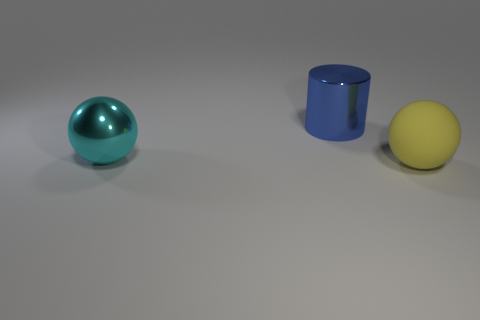There is a large yellow rubber thing; is its shape the same as the large metal thing on the left side of the cylinder?
Offer a very short reply. Yes. There is a large cyan object that is made of the same material as the big cylinder; what is its shape?
Offer a very short reply. Sphere. Are there more large blue cylinders that are behind the cyan thing than large blue cylinders that are behind the blue object?
Make the answer very short. Yes. What number of things are blue metallic cylinders or blue matte balls?
Give a very brief answer. 1. How many other things are the same color as the metal cylinder?
Offer a terse response. 0. There is a blue shiny thing that is the same size as the cyan ball; what shape is it?
Give a very brief answer. Cylinder. What color is the ball that is on the left side of the large rubber thing?
Your answer should be compact. Cyan. How many things are either large spheres that are to the left of the large yellow matte object or objects in front of the metal cylinder?
Give a very brief answer. 2. Is the matte object the same size as the cyan thing?
Your answer should be very brief. Yes. How many cubes are large cyan objects or rubber things?
Provide a succinct answer. 0. 